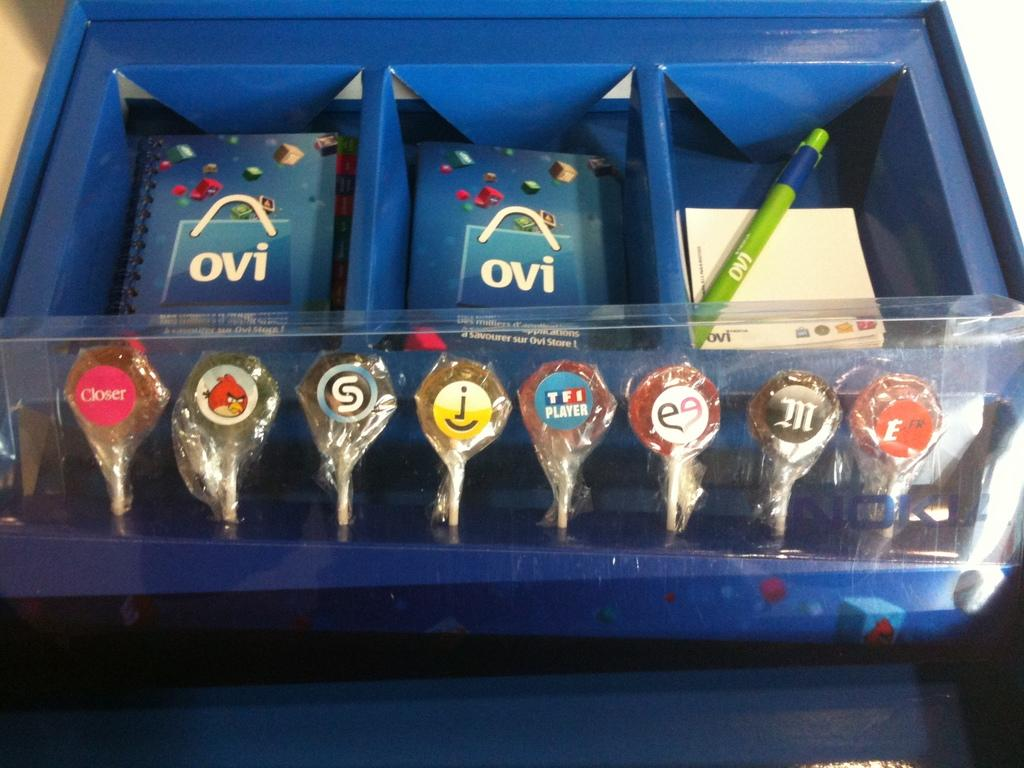<image>
Give a short and clear explanation of the subsequent image. a blue box with the word ovi on a paper item 